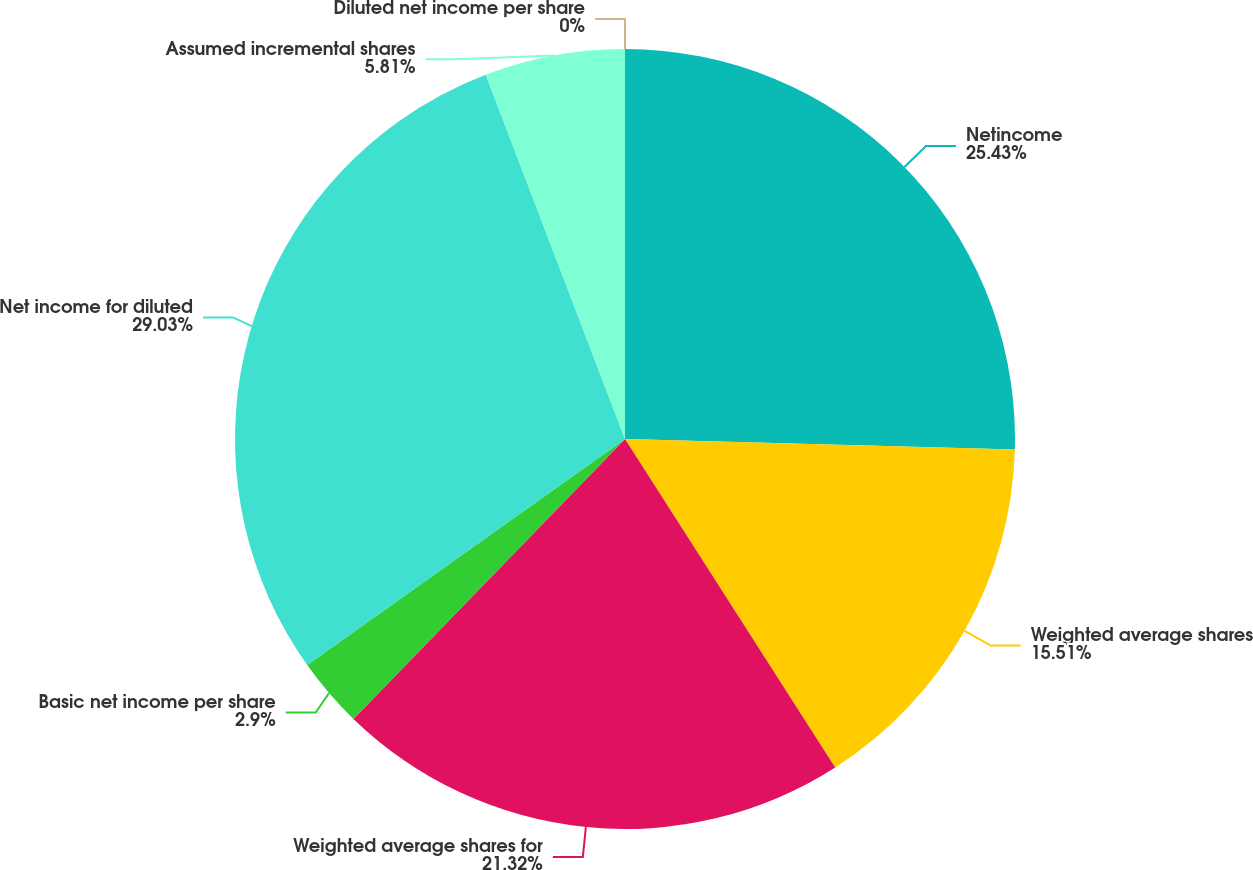<chart> <loc_0><loc_0><loc_500><loc_500><pie_chart><fcel>Netincome<fcel>Weighted average shares<fcel>Weighted average shares for<fcel>Basic net income per share<fcel>Net income for diluted<fcel>Assumed incremental shares<fcel>Diluted net income per share<nl><fcel>25.43%<fcel>15.51%<fcel>21.32%<fcel>2.9%<fcel>29.03%<fcel>5.81%<fcel>0.0%<nl></chart> 